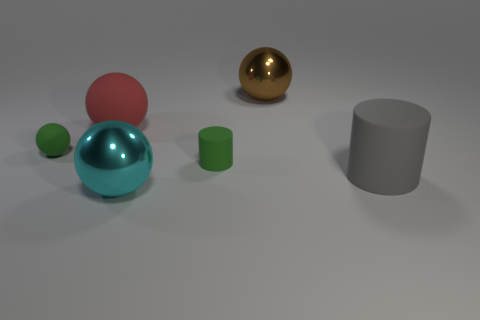What textures are represented by the objects and does the surface they are on reflect light? The objects exhibit various textures: the blue and gold spheres have shiny, reflective surfaces, indicating a smooth texture. The pink and green spheres have a matte finish suggesting a non-reflective, rougher texture. The gray cylinder is also matte. The surface upon which they rest is lightly reflective, as evidenced by the subtle reflections underneath the objects. 